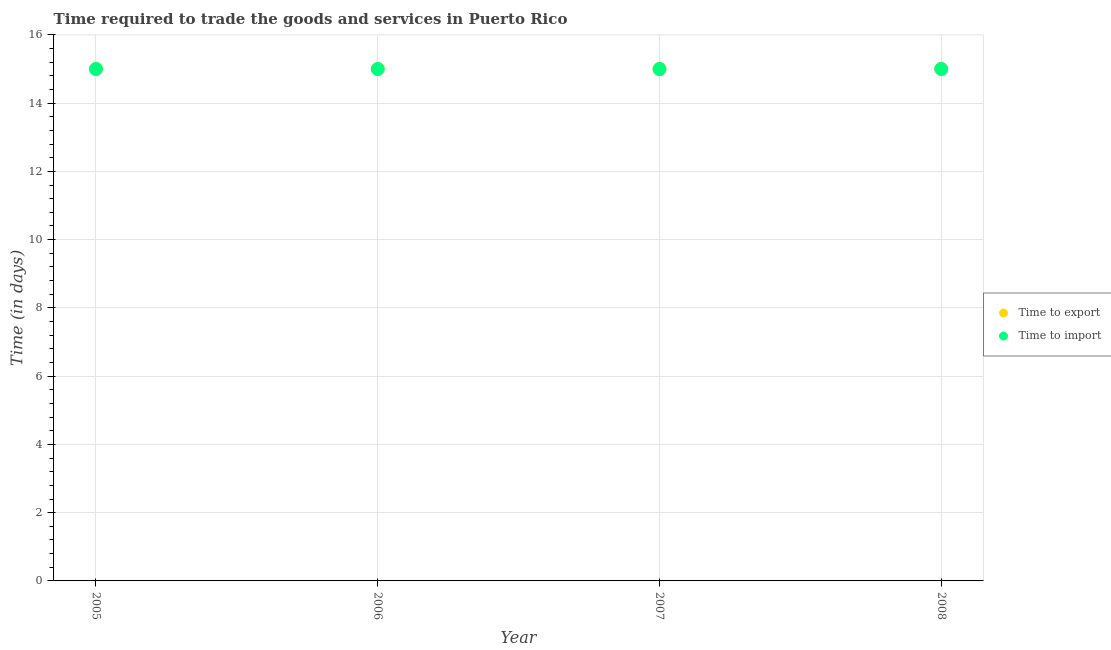Is the number of dotlines equal to the number of legend labels?
Provide a succinct answer. Yes. What is the time to export in 2006?
Your answer should be very brief. 15. Across all years, what is the maximum time to import?
Ensure brevity in your answer.  15. Across all years, what is the minimum time to import?
Your answer should be very brief. 15. In which year was the time to import maximum?
Give a very brief answer. 2005. In which year was the time to import minimum?
Keep it short and to the point. 2005. What is the total time to import in the graph?
Your response must be concise. 60. What is the difference between the time to import in 2005 and that in 2007?
Keep it short and to the point. 0. What is the average time to export per year?
Provide a short and direct response. 15. In the year 2006, what is the difference between the time to export and time to import?
Your answer should be compact. 0. Is the time to import in 2005 less than that in 2006?
Keep it short and to the point. No. Is the difference between the time to import in 2006 and 2008 greater than the difference between the time to export in 2006 and 2008?
Offer a very short reply. No. What is the difference between the highest and the lowest time to import?
Give a very brief answer. 0. Is the time to import strictly greater than the time to export over the years?
Offer a terse response. No. What is the difference between two consecutive major ticks on the Y-axis?
Keep it short and to the point. 2. Does the graph contain any zero values?
Provide a succinct answer. No. Does the graph contain grids?
Give a very brief answer. Yes. Where does the legend appear in the graph?
Offer a very short reply. Center right. How are the legend labels stacked?
Offer a very short reply. Vertical. What is the title of the graph?
Your response must be concise. Time required to trade the goods and services in Puerto Rico. What is the label or title of the X-axis?
Give a very brief answer. Year. What is the label or title of the Y-axis?
Keep it short and to the point. Time (in days). What is the Time (in days) of Time to export in 2005?
Provide a succinct answer. 15. What is the Time (in days) of Time to import in 2005?
Offer a very short reply. 15. What is the Time (in days) in Time to import in 2006?
Give a very brief answer. 15. What is the Time (in days) of Time to export in 2008?
Offer a terse response. 15. What is the Time (in days) in Time to import in 2008?
Your response must be concise. 15. Across all years, what is the minimum Time (in days) in Time to export?
Your answer should be compact. 15. What is the total Time (in days) in Time to import in the graph?
Provide a short and direct response. 60. What is the difference between the Time (in days) in Time to export in 2005 and that in 2006?
Offer a very short reply. 0. What is the difference between the Time (in days) of Time to import in 2005 and that in 2006?
Provide a succinct answer. 0. What is the difference between the Time (in days) in Time to export in 2005 and that in 2007?
Offer a very short reply. 0. What is the difference between the Time (in days) in Time to import in 2005 and that in 2008?
Offer a very short reply. 0. What is the difference between the Time (in days) in Time to import in 2006 and that in 2007?
Offer a terse response. 0. What is the difference between the Time (in days) in Time to import in 2006 and that in 2008?
Offer a very short reply. 0. What is the difference between the Time (in days) in Time to export in 2007 and that in 2008?
Provide a short and direct response. 0. What is the difference between the Time (in days) of Time to export in 2005 and the Time (in days) of Time to import in 2007?
Your answer should be very brief. 0. What is the difference between the Time (in days) in Time to export in 2006 and the Time (in days) in Time to import in 2008?
Offer a terse response. 0. What is the difference between the Time (in days) of Time to export in 2007 and the Time (in days) of Time to import in 2008?
Make the answer very short. 0. In the year 2006, what is the difference between the Time (in days) of Time to export and Time (in days) of Time to import?
Provide a succinct answer. 0. In the year 2008, what is the difference between the Time (in days) of Time to export and Time (in days) of Time to import?
Offer a very short reply. 0. What is the ratio of the Time (in days) in Time to export in 2005 to that in 2006?
Your response must be concise. 1. What is the ratio of the Time (in days) in Time to import in 2005 to that in 2006?
Make the answer very short. 1. What is the ratio of the Time (in days) of Time to import in 2005 to that in 2007?
Your response must be concise. 1. What is the ratio of the Time (in days) of Time to export in 2005 to that in 2008?
Give a very brief answer. 1. What is the ratio of the Time (in days) of Time to import in 2005 to that in 2008?
Provide a succinct answer. 1. What is the ratio of the Time (in days) in Time to export in 2006 to that in 2008?
Ensure brevity in your answer.  1. What is the ratio of the Time (in days) in Time to import in 2006 to that in 2008?
Offer a very short reply. 1. What is the ratio of the Time (in days) in Time to import in 2007 to that in 2008?
Your response must be concise. 1. What is the difference between the highest and the second highest Time (in days) in Time to export?
Your answer should be compact. 0. 